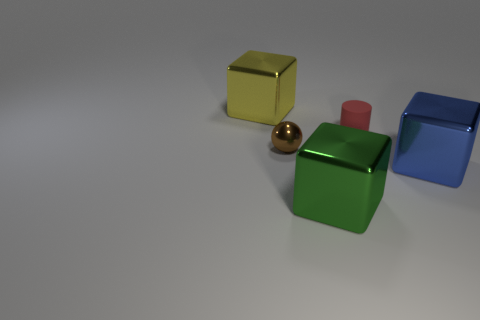What number of other things are there of the same size as the cylinder?
Your answer should be compact. 1. Do the small sphere and the large block that is in front of the blue block have the same color?
Ensure brevity in your answer.  No. What number of blocks are either purple matte objects or yellow objects?
Make the answer very short. 1. Is there any other thing of the same color as the small metallic ball?
Your answer should be very brief. No. There is a yellow thing behind the tiny object that is on the right side of the tiny brown metallic object; what is it made of?
Your answer should be compact. Metal. Does the large blue thing have the same material as the block left of the small brown thing?
Offer a terse response. Yes. What number of objects are large things that are on the right side of the green metal thing or small matte cylinders?
Your response must be concise. 2. Is there another matte cylinder that has the same color as the cylinder?
Ensure brevity in your answer.  No. There is a large yellow object; does it have the same shape as the metal object that is in front of the large blue block?
Your answer should be compact. Yes. How many things are both in front of the tiny matte object and left of the small red matte thing?
Ensure brevity in your answer.  2. 